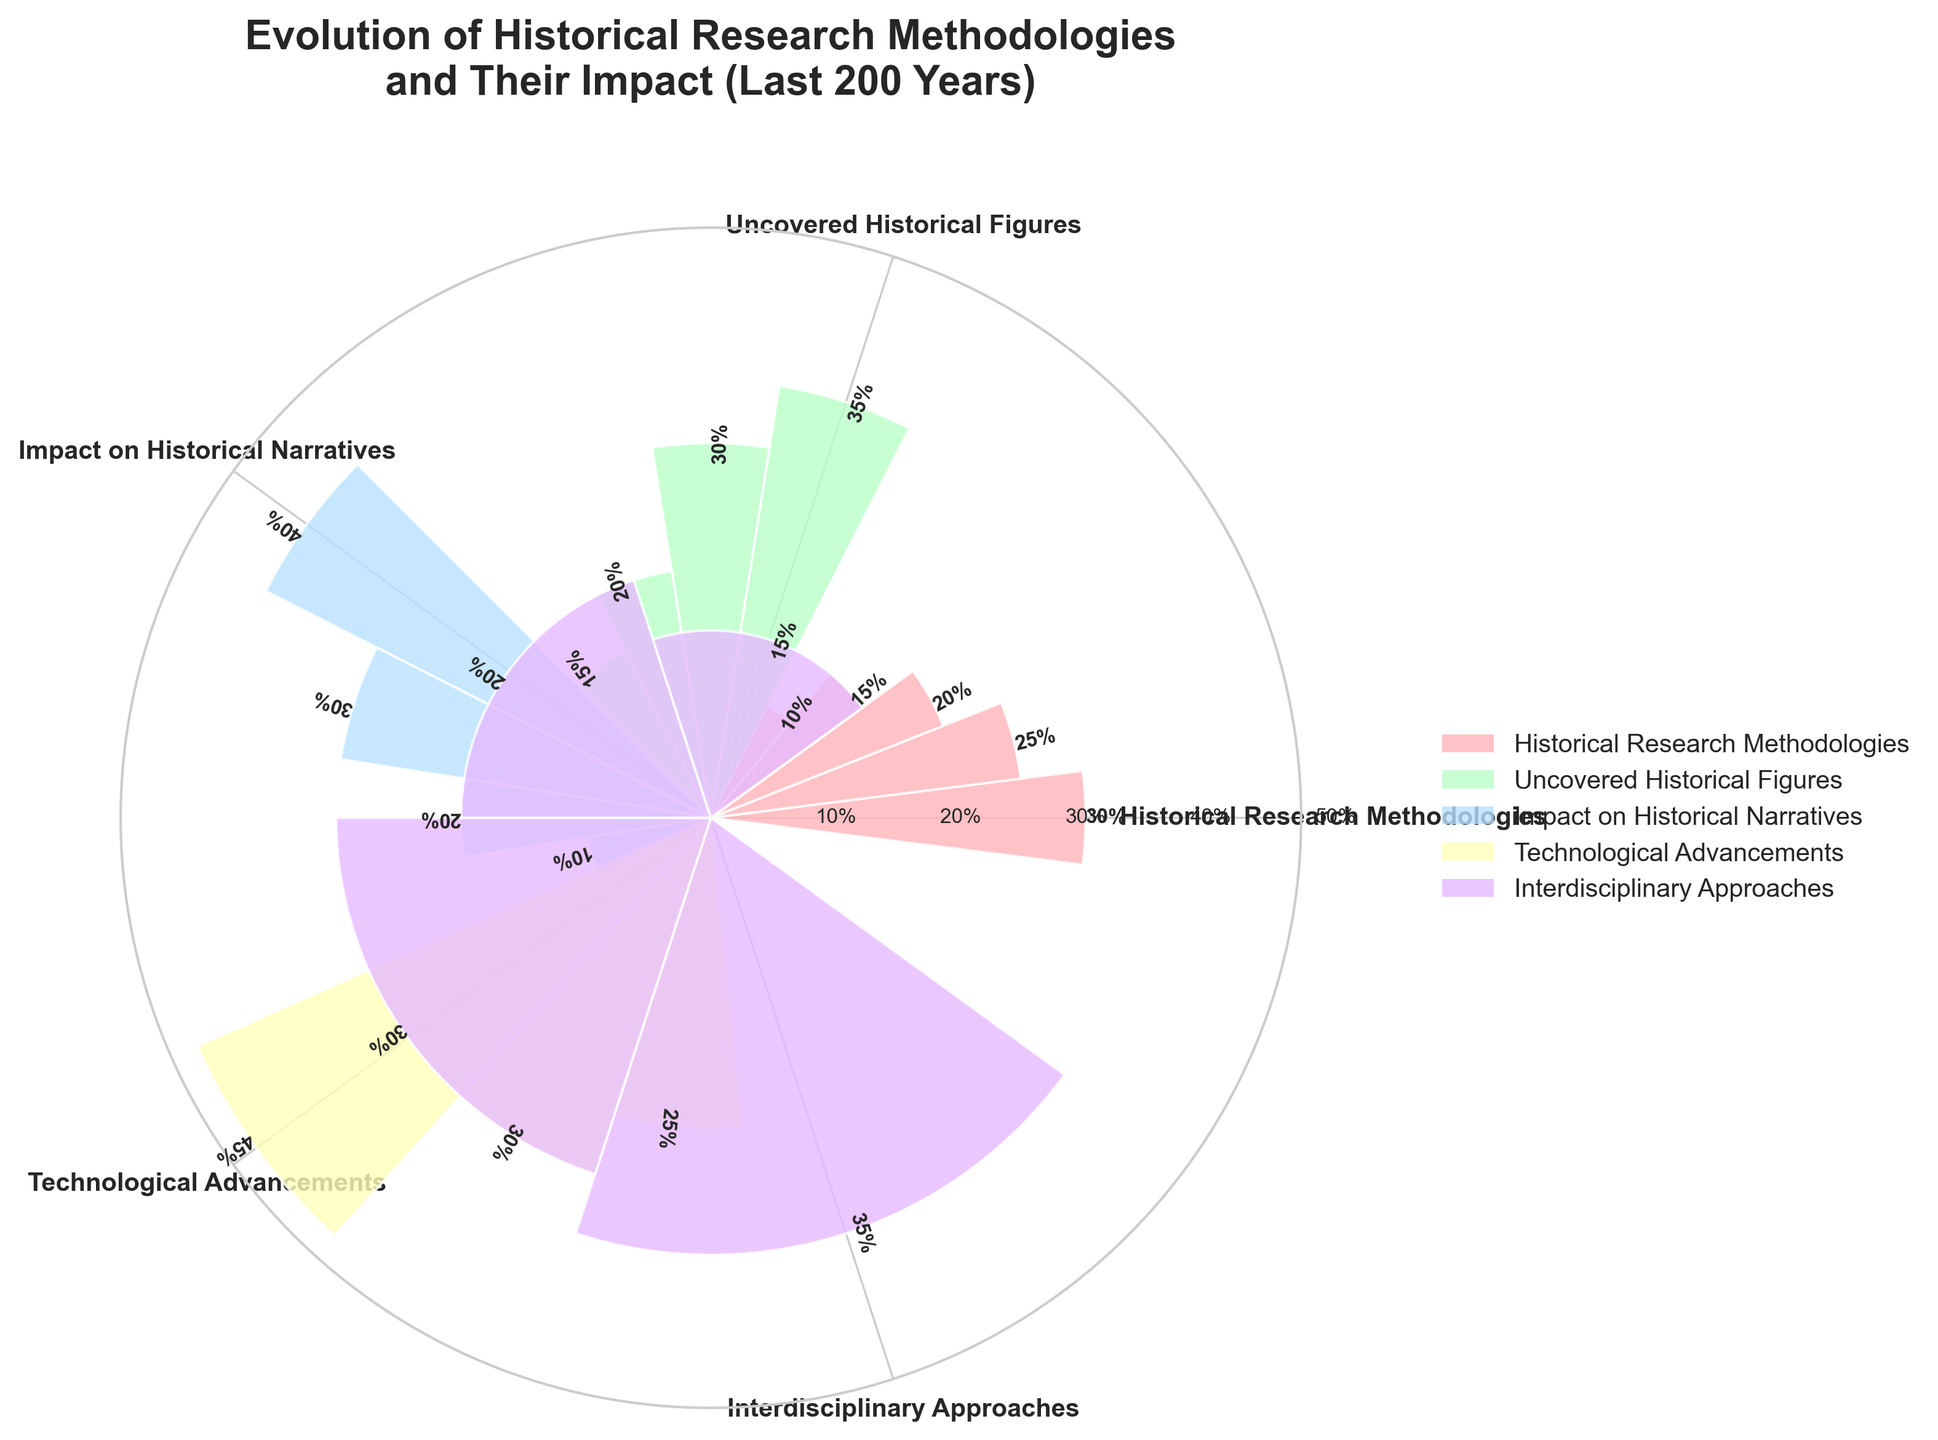What is the highest value observed for the "Technological Advancements" category? In the figure, the "Technological Advancements" category comprises multiple bars. We look at the height of each bar in this category to find the highest value. The tallest bar represents "Digitization of Archives" with a value of 45%.
Answer: 45% Which category has the most bars in the figure? We examine the number of bars under each category in the figure. The category "Historical Research Methodologies" has 5 bars, more than any other category.
Answer: Historical Research Methodologies What is the sum of values for "Uncovered Historical Figures"? The "Uncovered Historical Figures" category has values of 35, 30, 20, and 15. Summing up these values: 35 + 30 + 20 + 15 = 100.
Answer: 100 Which has a higher value, "Diverse Perspectives" from "Impact on Historical Narratives" or "AI-assisted Research" from "Technological Advancements"? Comparing the heights of the respective bars: "Diverse Perspectives" has a value of 40% and "AI-assisted Research" has a value of 30%.
Answer: Diverse Perspectives What is the average value of the category "Interdisciplinary Approaches"? The values in the "Interdisciplinary Approaches" category are 35, 30, 20, and 15. The mean value is calculated as (35 + 30 + 20 + 15) / 4 = 100 / 4 = 25.
Answer: 25 Which specific research methodology has the lowest recorded value? In "Historical Research Methodologies", the bars represent different methodologies. The bar for "Archaeological Techniques" is the shortest and has a value of 10%.
Answer: Archaeological Techniques If you sum the highest values of each category, what is the result? The highest values of each category are 30, 35, 40, 45, and 35 respectively. Adding these together: 30 + 35 + 40 + 45 + 35 = 185.
Answer: 185 Which category has the broadest impact on challenging Eurocentric views? In the "Impact on Historical Narratives" category, the bar labeled "Challenging Eurocentric Views" is the one we need to assess, and it has a value of 30%.
Answer: Impact on Historical Narratives What is the difference between the highest value in "Interdisciplinary Approaches" and "Uncovered Historical Figures"? The highest value in "Interdisciplinary Approaches" is 35 and in "Uncovered Historical Figures" is also 35. The difference is 35 - 35 = 0.
Answer: 0 How many categories have values that reach at least 40? We observe that "Impact on Historical Narratives" with "Diverse Perspectives" and "Technological Advancements" with "Digitization of Archives" both have bars that reach 40% or more.
Answer: 2 categories 